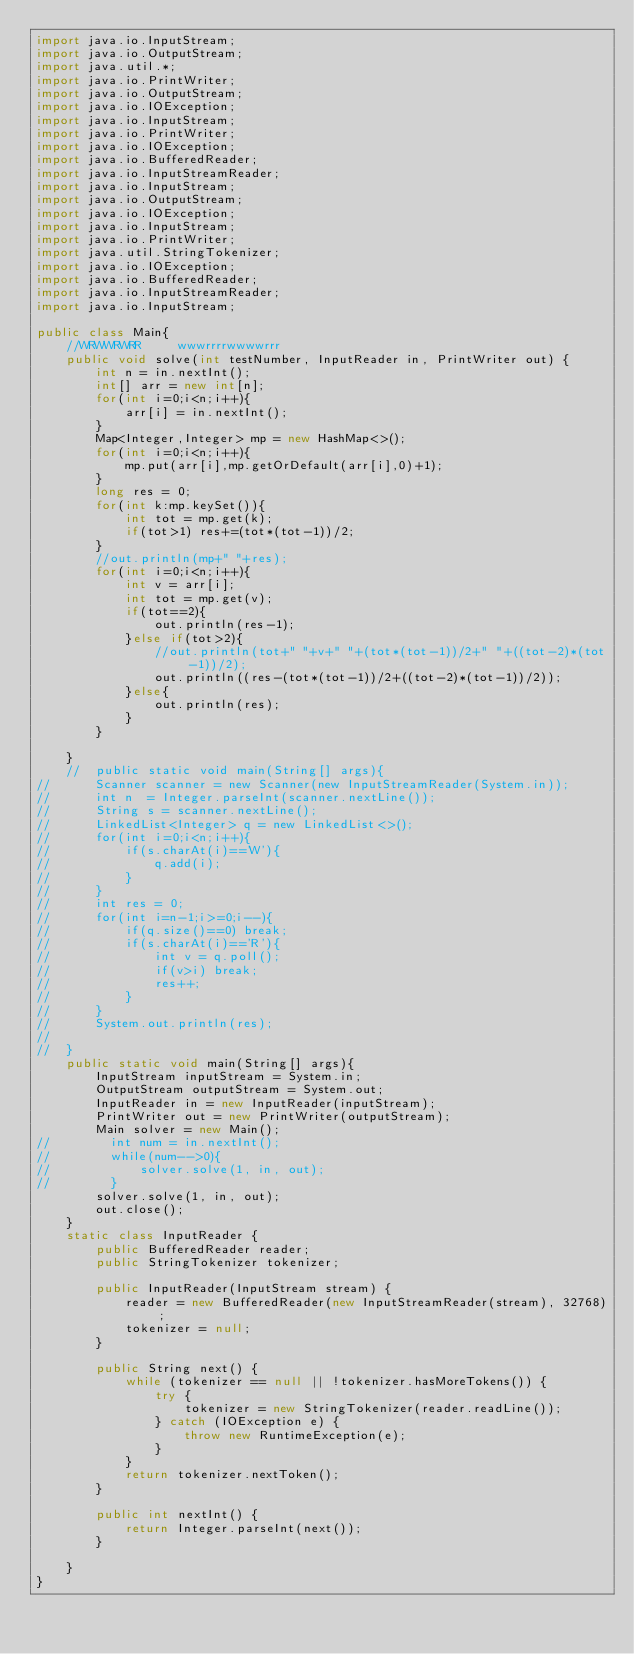<code> <loc_0><loc_0><loc_500><loc_500><_Java_>import java.io.InputStream;
import java.io.OutputStream;
import java.util.*;
import java.io.PrintWriter;
import java.io.OutputStream;
import java.io.IOException;
import java.io.InputStream;
import java.io.PrintWriter;
import java.io.IOException;
import java.io.BufferedReader;
import java.io.InputStreamReader;
import java.io.InputStream;
import java.io.OutputStream;
import java.io.IOException;
import java.io.InputStream;
import java.io.PrintWriter;
import java.util.StringTokenizer;
import java.io.IOException;
import java.io.BufferedReader;
import java.io.InputStreamReader;
import java.io.InputStream;

public class Main{
    //WRWWRWRR     wwwrrrrwwwwrrr
    public void solve(int testNumber, InputReader in, PrintWriter out) {
        int n = in.nextInt();
        int[] arr = new int[n];
        for(int i=0;i<n;i++){
            arr[i] = in.nextInt();
        }
        Map<Integer,Integer> mp = new HashMap<>();
        for(int i=0;i<n;i++){
            mp.put(arr[i],mp.getOrDefault(arr[i],0)+1);
        }
        long res = 0;
        for(int k:mp.keySet()){
            int tot = mp.get(k);
            if(tot>1) res+=(tot*(tot-1))/2;
        }
        //out.println(mp+" "+res);
        for(int i=0;i<n;i++){
            int v = arr[i];
            int tot = mp.get(v);
            if(tot==2){
                out.println(res-1);
            }else if(tot>2){
                //out.println(tot+" "+v+" "+(tot*(tot-1))/2+" "+((tot-2)*(tot-1))/2);
                out.println((res-(tot*(tot-1))/2+((tot-2)*(tot-1))/2));
            }else{
                out.println(res);
            }
        }

    }
    //	public static void main(String[] args){
//		Scanner scanner = new Scanner(new InputStreamReader(System.in));
//		int n  = Integer.parseInt(scanner.nextLine());
//		String s = scanner.nextLine();
//		LinkedList<Integer> q = new LinkedList<>();
//		for(int i=0;i<n;i++){
//			if(s.charAt(i)=='W'){
//				q.add(i);
//			}
//		}
//		int res = 0;
//		for(int i=n-1;i>=0;i--){
//			if(q.size()==0) break;
//			if(s.charAt(i)=='R'){
//				int v = q.poll();
//				if(v>i) break;
//				res++;
//			}
//		}
//		System.out.println(res);
//
//	}
    public static void main(String[] args){
        InputStream inputStream = System.in;
        OutputStream outputStream = System.out;
        InputReader in = new InputReader(inputStream);
        PrintWriter out = new PrintWriter(outputStream);
        Main solver = new Main();
//        int num = in.nextInt();
//        while(num-->0){
//            solver.solve(1, in, out);
//        }
        solver.solve(1, in, out);
        out.close();
    }
    static class InputReader {
        public BufferedReader reader;
        public StringTokenizer tokenizer;

        public InputReader(InputStream stream) {
            reader = new BufferedReader(new InputStreamReader(stream), 32768);
            tokenizer = null;
        }

        public String next() {
            while (tokenizer == null || !tokenizer.hasMoreTokens()) {
                try {
                    tokenizer = new StringTokenizer(reader.readLine());
                } catch (IOException e) {
                    throw new RuntimeException(e);
                }
            }
            return tokenizer.nextToken();
        }

        public int nextInt() {
            return Integer.parseInt(next());
        }

    }
}</code> 